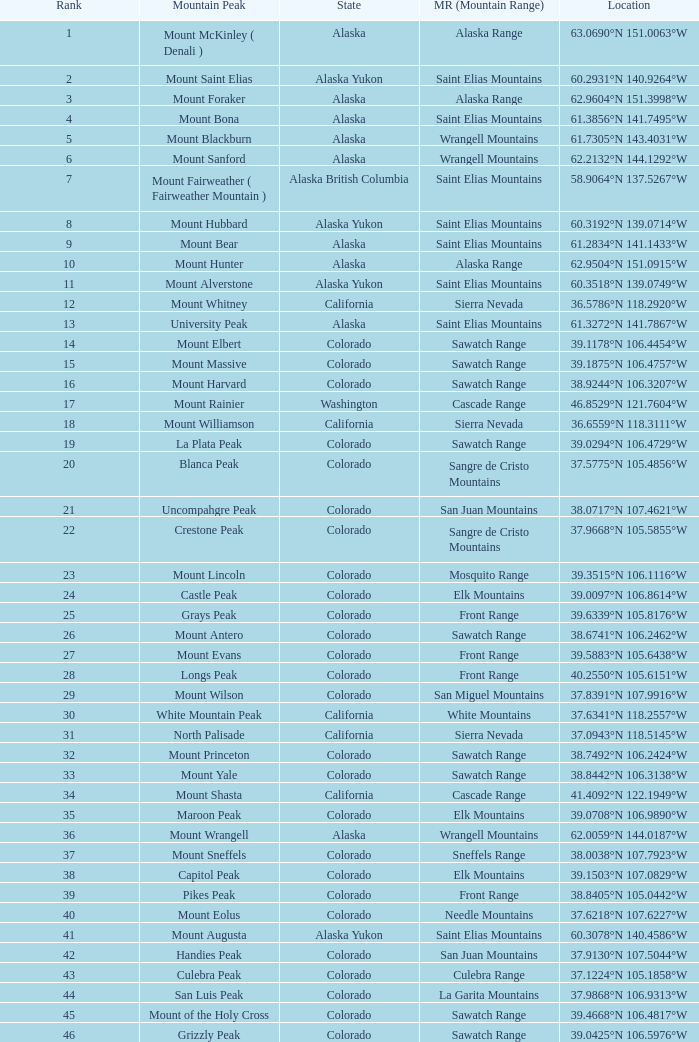What is the mountain range when the state is colorado, rank is higher than 90 and mountain peak is whetstone mountain? West Elk Mountains. 